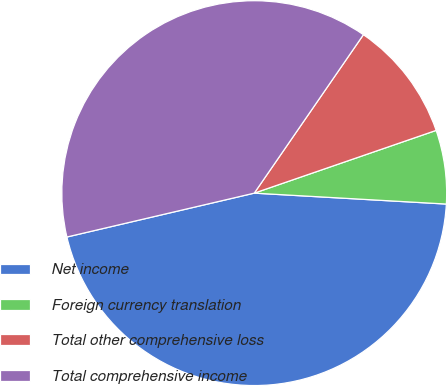Convert chart. <chart><loc_0><loc_0><loc_500><loc_500><pie_chart><fcel>Net income<fcel>Foreign currency translation<fcel>Total other comprehensive loss<fcel>Total comprehensive income<nl><fcel>45.43%<fcel>6.19%<fcel>10.11%<fcel>38.26%<nl></chart> 